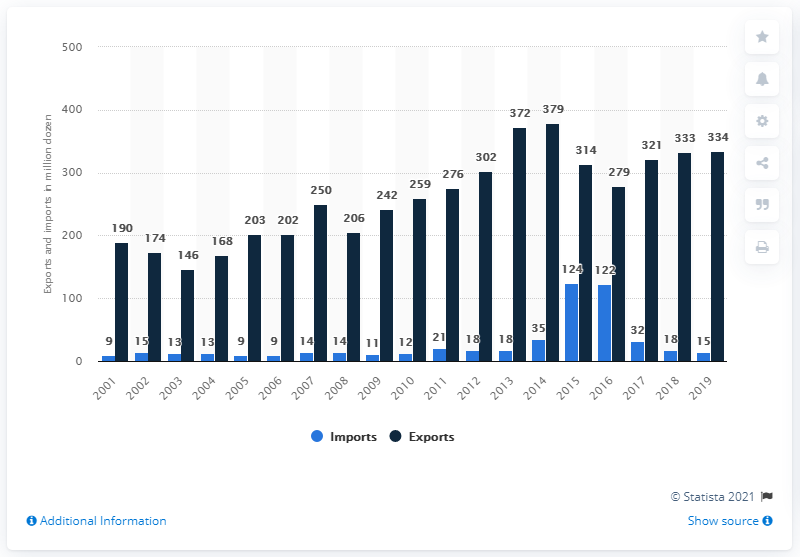Mention a couple of crucial points in this snapshot. In 2019, a total of 15 eggs were imported. In 2019, a total of 334 eggs were exported. 